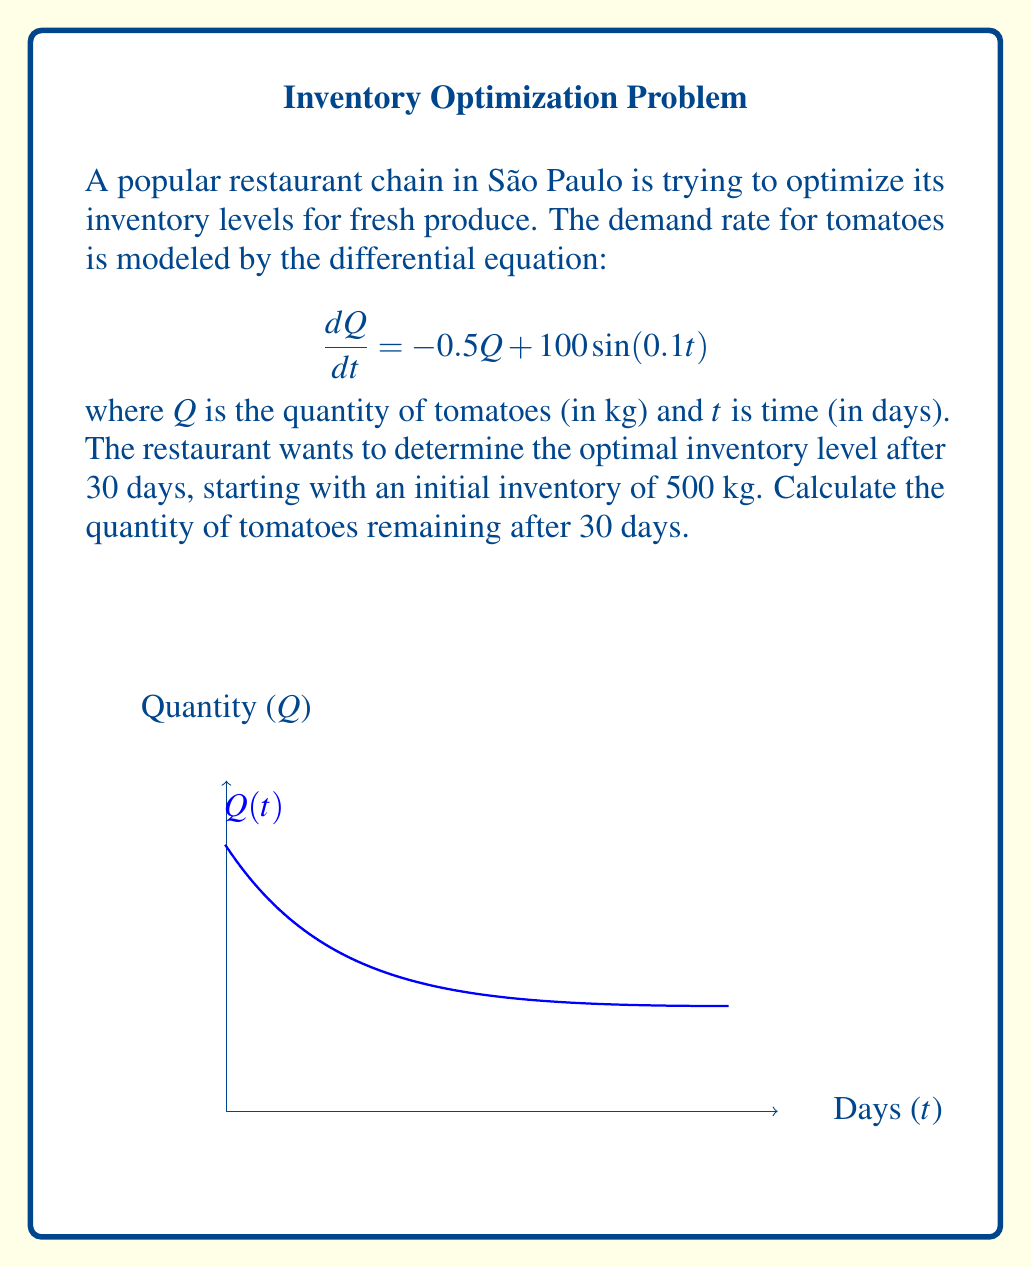Solve this math problem. To solve this problem, we need to use the method for solving first-order linear differential equations:

1) The general form of the equation is:
   $$\frac{dQ}{dt} + 0.5Q = 100\sin(0.1t)$$

2) The integrating factor is:
   $$\mu(t) = e^{\int 0.5 dt} = e^{0.5t}$$

3) Multiplying both sides by the integrating factor:
   $$e^{0.5t}\frac{dQ}{dt} + 0.5e^{0.5t}Q = 100e^{0.5t}\sin(0.1t)$$

4) This can be rewritten as:
   $$\frac{d}{dt}(e^{0.5t}Q) = 100e^{0.5t}\sin(0.1t)$$

5) Integrating both sides:
   $$e^{0.5t}Q = \int 100e^{0.5t}\sin(0.1t)dt$$

6) Solving the integral:
   $$e^{0.5t}Q = 100(\frac{5e^{0.5t}\sin(0.1t) - e^{0.5t}\cos(0.1t)}{26}) + C$$

7) Solving for Q:
   $$Q = 200 + \frac{500\sin(0.1t) - 100\cos(0.1t)}{\sqrt{26}} + Ce^{-0.5t}$$

8) Using the initial condition Q(0) = 500:
   $$500 = 200 - \frac{100}{\sqrt{26}} + C$$
   $$C = 300 + \frac{100}{\sqrt{26}}$$

9) The final solution is:
   $$Q(t) = 200 + \frac{500\sin(0.1t) - 100\cos(0.1t)}{\sqrt{26}} + (300 + \frac{100}{\sqrt{26}})e^{-0.5t}$$

10) Evaluating at t = 30:
    $$Q(30) = 200 + \frac{500\sin(3) - 100\cos(3)}{\sqrt{26}} + (300 + \frac{100}{\sqrt{26}})e^{-15}$$

11) Calculating the final value:
    $$Q(30) \approx 237.8 \text{ kg}$$
Answer: 237.8 kg 